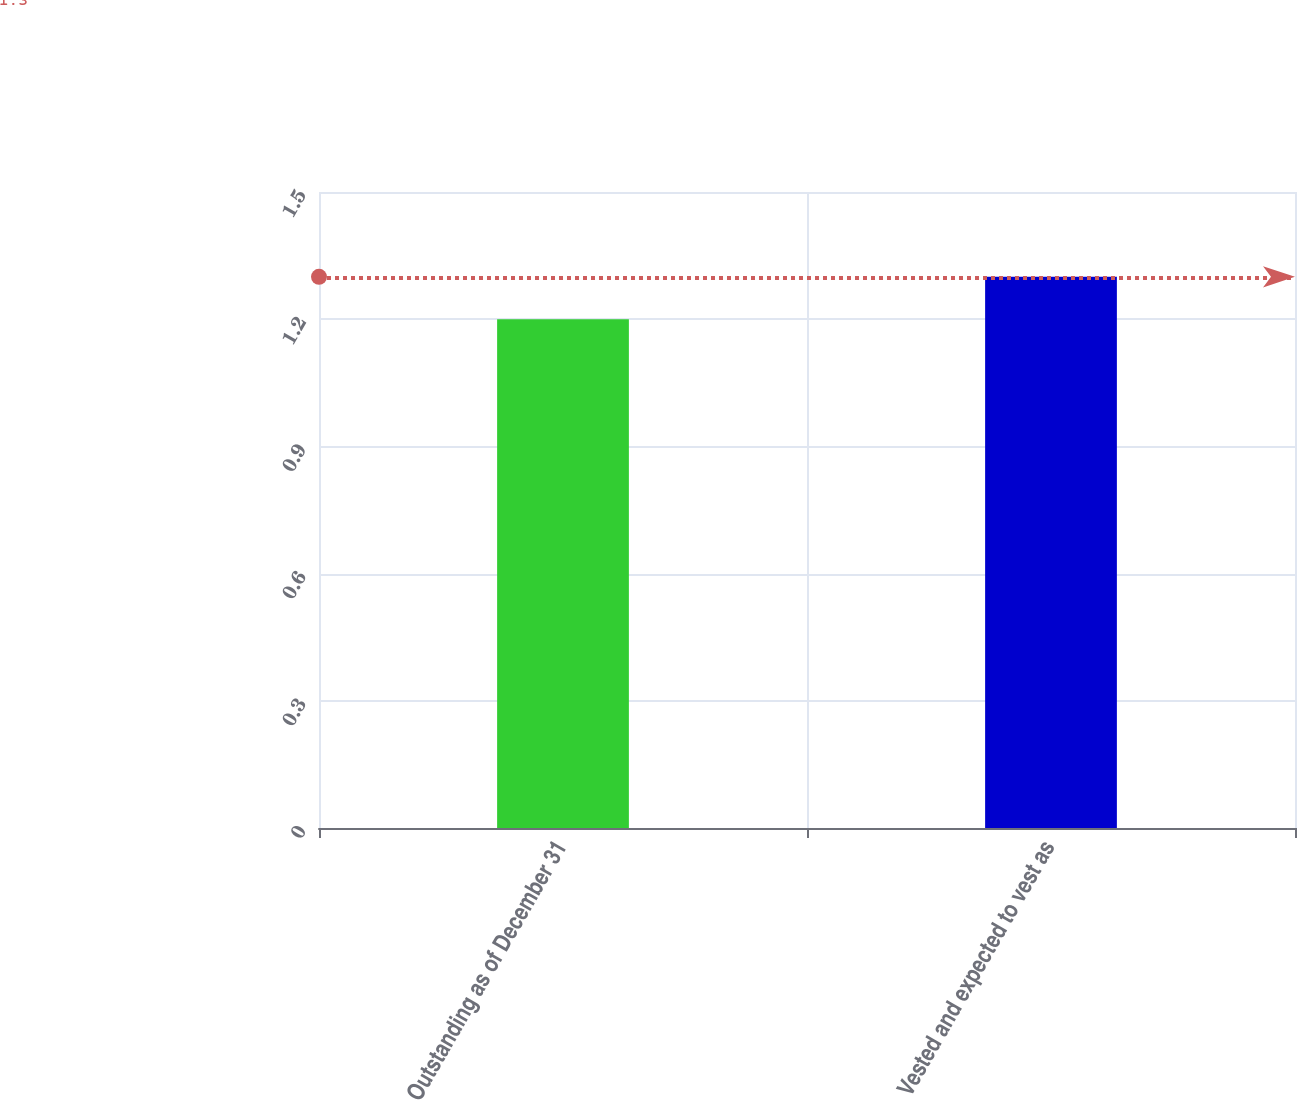<chart> <loc_0><loc_0><loc_500><loc_500><bar_chart><fcel>Outstanding as of December 31<fcel>Vested and expected to vest as<nl><fcel>1.2<fcel>1.3<nl></chart> 